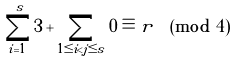Convert formula to latex. <formula><loc_0><loc_0><loc_500><loc_500>\sum _ { i = 1 } ^ { s } 3 + \sum _ { 1 \leq i < j \leq s } 0 \equiv r \pmod { 4 }</formula> 